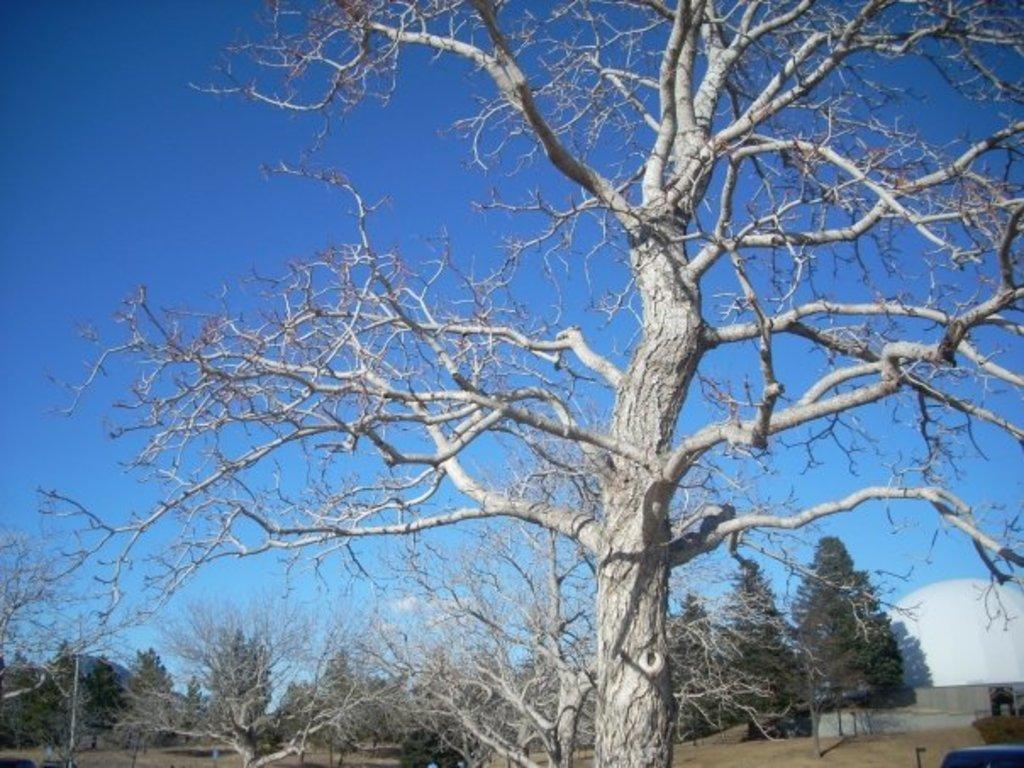What type of natural elements can be seen in the image? There are trees in the image. What type of structure is visible in the background of the image? There is a dome-shaped architecture in the background of the image. What is visible in the sky in the image? The sky is visible in the background of the image. What type of sofa can be seen in the image? There is no sofa present in the image. How many feet are visible in the image? There are no feet visible in the image. 